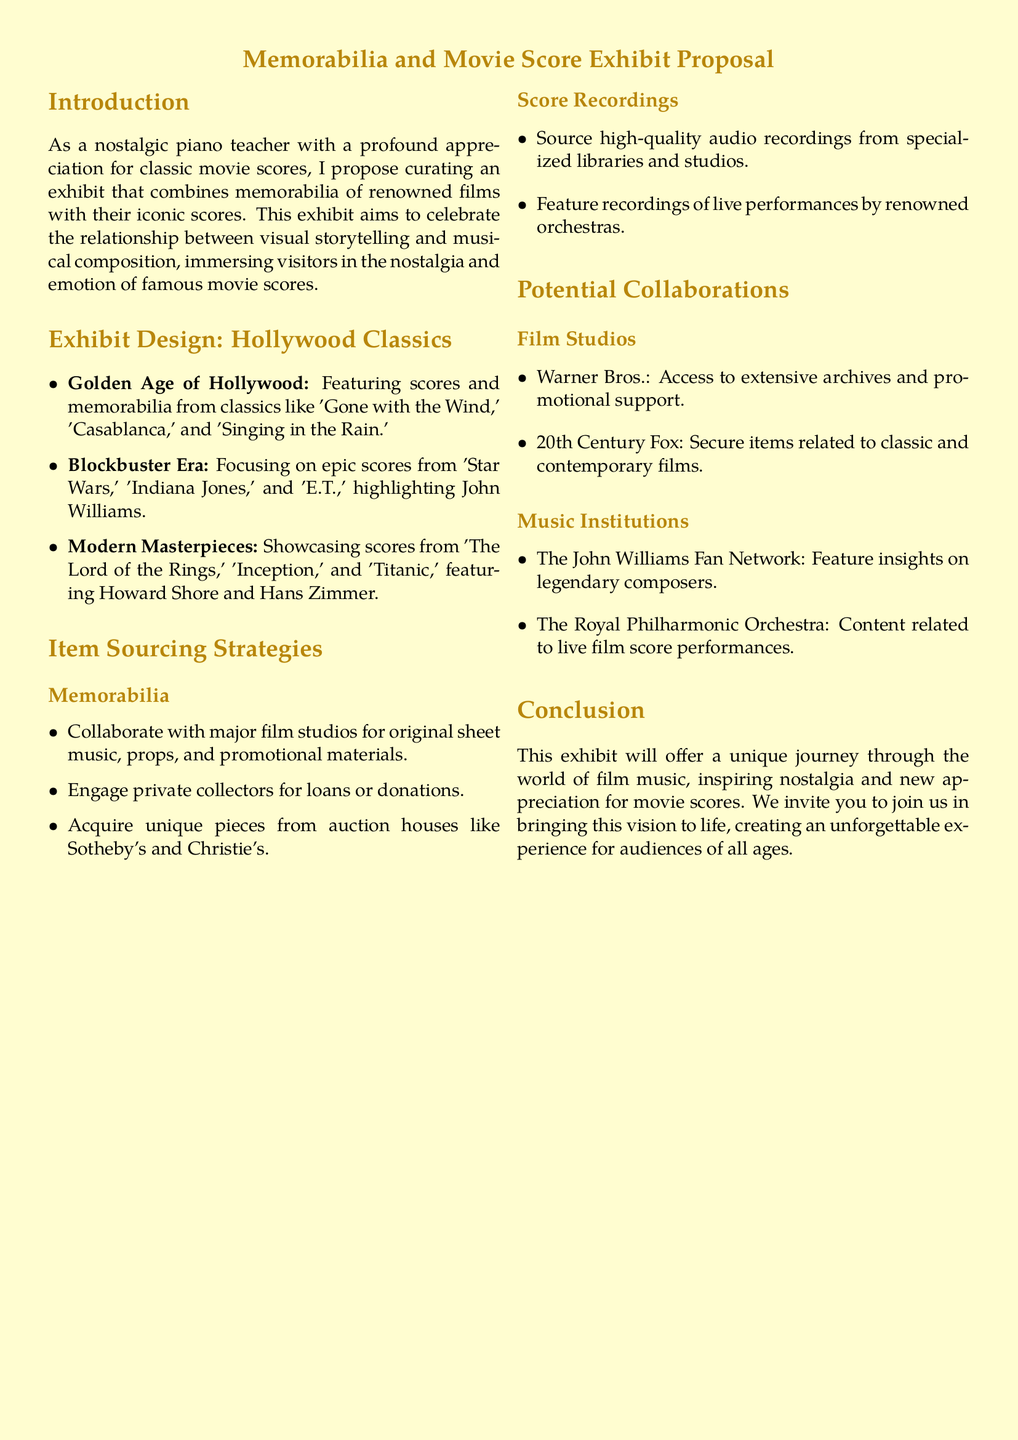What is the title of the proposal? The title is stated at the beginning of the document and highlights the main focus of the exhibit.
Answer: Memorabilia and Movie Score Exhibit Proposal What era features scores from 'Gone with the Wind'? This era is specifically designated in the exhibit design section, highlighting the focus on classic films.
Answer: Golden Age of Hollywood Which film is associated with John Williams? The document mentions several films in the Blockbuster Era, with John Williams' work particularly noted.
Answer: Star Wars What type of items will be sourced from auction houses? The sourcing strategy section lists various strategies for acquiring memorabilia, including a specific source for unique pieces.
Answer: Unique pieces Which organization is listed for potential collaboration regarding live performances? The proposal mentions institutions for collaboration, one of which focuses on orchestral performances related to film scores.
Answer: The Royal Philharmonic Orchestra How many sections are there in the exhibit design? The document outlines different sections in the design part, indicating the number of specific focuses.
Answer: Three What is one of the sources for score recordings? The document specifies various sources for recordings, which relate to high-quality audio collections.
Answer: Specialized libraries Who may provide promotional support according to potential collaborations? The section about collaborations identifies this particular film studio's role in offering support for the exhibit.
Answer: Warner Bros 